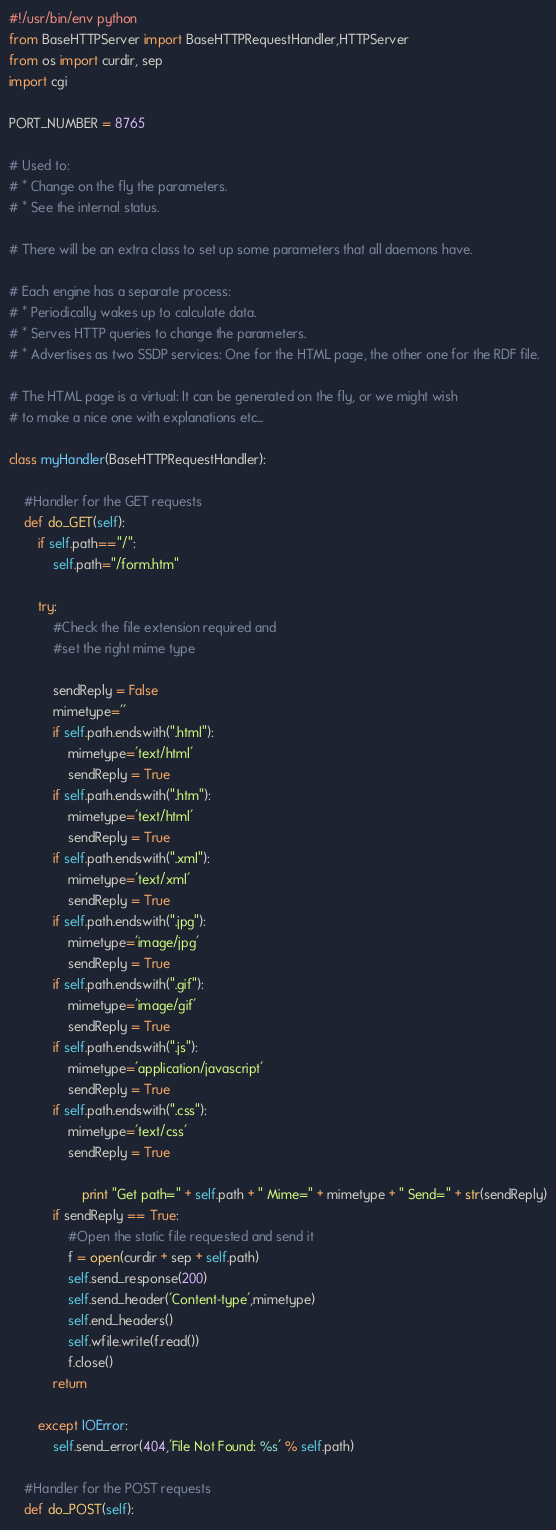Convert code to text. <code><loc_0><loc_0><loc_500><loc_500><_Python_>#!/usr/bin/env python
from BaseHTTPServer import BaseHTTPRequestHandler,HTTPServer
from os import curdir, sep
import cgi

PORT_NUMBER = 8765

# Used to:
# * Change on the fly the parameters.
# * See the internal status.

# There will be an extra class to set up some parameters that all daemons have.

# Each engine has a separate process:
# * Periodically wakes up to calculate data.
# * Serves HTTP queries to change the parameters.
# * Advertises as two SSDP services: One for the HTML page, the other one for the RDF file.

# The HTML page is a virtual: It can be generated on the fly, or we might wish
# to make a nice one with explanations etc...

class myHandler(BaseHTTPRequestHandler):
	
	#Handler for the GET requests
	def do_GET(self):
		if self.path=="/":
			self.path="/form.htm"

		try:
			#Check the file extension required and
			#set the right mime type

			sendReply = False
			mimetype=''
			if self.path.endswith(".html"):
				mimetype='text/html'
				sendReply = True
			if self.path.endswith(".htm"):
				mimetype='text/html'
				sendReply = True
			if self.path.endswith(".xml"):
				mimetype='text/xml'
				sendReply = True
			if self.path.endswith(".jpg"):
				mimetype='image/jpg'
				sendReply = True
			if self.path.endswith(".gif"):
				mimetype='image/gif'
				sendReply = True
			if self.path.endswith(".js"):
				mimetype='application/javascript'
				sendReply = True
			if self.path.endswith(".css"):
				mimetype='text/css'
				sendReply = True

                	print "Get path=" + self.path + " Mime=" + mimetype + " Send=" + str(sendReply)
			if sendReply == True:
				#Open the static file requested and send it
				f = open(curdir + sep + self.path) 
				self.send_response(200)
				self.send_header('Content-type',mimetype)
				self.end_headers()
				self.wfile.write(f.read())
				f.close()
			return

		except IOError:
			self.send_error(404,'File Not Found: %s' % self.path)

	#Handler for the POST requests
	def do_POST(self):</code> 